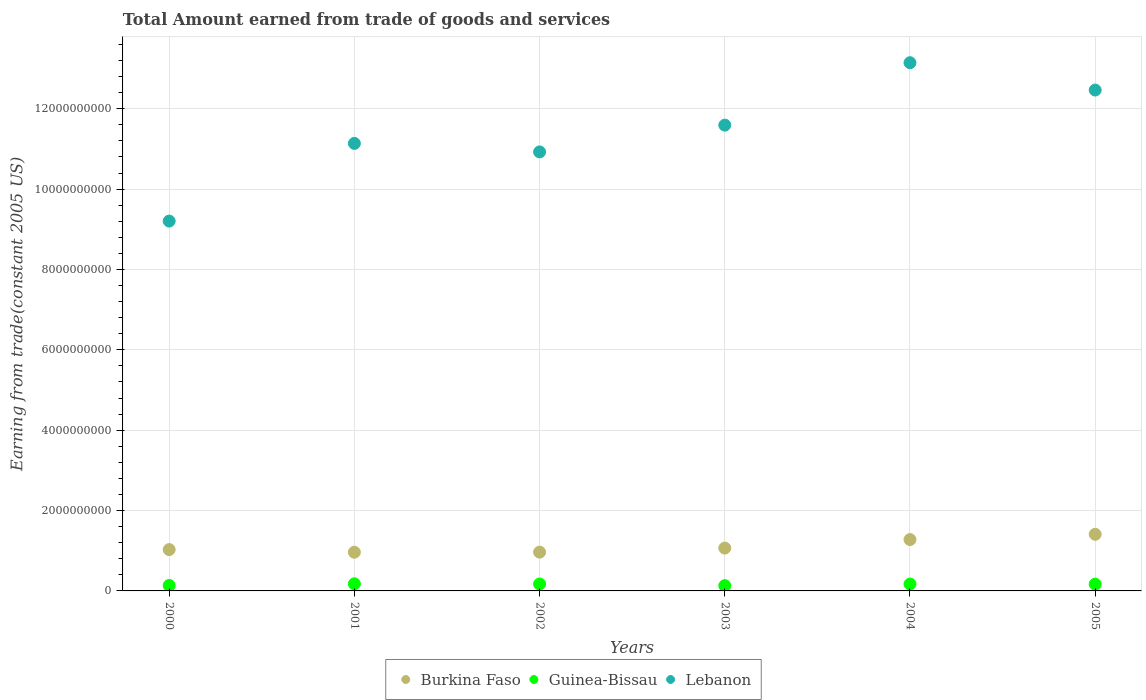What is the total amount earned by trading goods and services in Burkina Faso in 2001?
Give a very brief answer. 9.63e+08. Across all years, what is the maximum total amount earned by trading goods and services in Lebanon?
Your answer should be compact. 1.31e+1. Across all years, what is the minimum total amount earned by trading goods and services in Lebanon?
Your answer should be very brief. 9.20e+09. In which year was the total amount earned by trading goods and services in Burkina Faso maximum?
Your response must be concise. 2005. What is the total total amount earned by trading goods and services in Lebanon in the graph?
Keep it short and to the point. 6.85e+1. What is the difference between the total amount earned by trading goods and services in Burkina Faso in 2001 and that in 2002?
Ensure brevity in your answer.  -2.19e+06. What is the difference between the total amount earned by trading goods and services in Lebanon in 2005 and the total amount earned by trading goods and services in Burkina Faso in 2000?
Your response must be concise. 1.14e+1. What is the average total amount earned by trading goods and services in Lebanon per year?
Your response must be concise. 1.14e+1. In the year 2000, what is the difference between the total amount earned by trading goods and services in Guinea-Bissau and total amount earned by trading goods and services in Burkina Faso?
Give a very brief answer. -8.93e+08. In how many years, is the total amount earned by trading goods and services in Guinea-Bissau greater than 4400000000 US$?
Provide a succinct answer. 0. What is the ratio of the total amount earned by trading goods and services in Guinea-Bissau in 2001 to that in 2004?
Keep it short and to the point. 1.04. Is the total amount earned by trading goods and services in Guinea-Bissau in 2001 less than that in 2004?
Your answer should be compact. No. Is the difference between the total amount earned by trading goods and services in Guinea-Bissau in 2000 and 2003 greater than the difference between the total amount earned by trading goods and services in Burkina Faso in 2000 and 2003?
Provide a succinct answer. Yes. What is the difference between the highest and the second highest total amount earned by trading goods and services in Lebanon?
Make the answer very short. 6.80e+08. What is the difference between the highest and the lowest total amount earned by trading goods and services in Guinea-Bissau?
Provide a succinct answer. 4.55e+07. Is the sum of the total amount earned by trading goods and services in Guinea-Bissau in 2001 and 2005 greater than the maximum total amount earned by trading goods and services in Burkina Faso across all years?
Keep it short and to the point. No. Does the total amount earned by trading goods and services in Guinea-Bissau monotonically increase over the years?
Make the answer very short. No. Is the total amount earned by trading goods and services in Lebanon strictly less than the total amount earned by trading goods and services in Guinea-Bissau over the years?
Ensure brevity in your answer.  No. How many dotlines are there?
Offer a terse response. 3. How many years are there in the graph?
Provide a succinct answer. 6. Are the values on the major ticks of Y-axis written in scientific E-notation?
Your answer should be compact. No. What is the title of the graph?
Offer a terse response. Total Amount earned from trade of goods and services. What is the label or title of the X-axis?
Provide a succinct answer. Years. What is the label or title of the Y-axis?
Provide a short and direct response. Earning from trade(constant 2005 US). What is the Earning from trade(constant 2005 US) of Burkina Faso in 2000?
Your answer should be very brief. 1.03e+09. What is the Earning from trade(constant 2005 US) of Guinea-Bissau in 2000?
Keep it short and to the point. 1.35e+08. What is the Earning from trade(constant 2005 US) of Lebanon in 2000?
Ensure brevity in your answer.  9.20e+09. What is the Earning from trade(constant 2005 US) in Burkina Faso in 2001?
Your response must be concise. 9.63e+08. What is the Earning from trade(constant 2005 US) in Guinea-Bissau in 2001?
Provide a short and direct response. 1.77e+08. What is the Earning from trade(constant 2005 US) of Lebanon in 2001?
Offer a very short reply. 1.11e+1. What is the Earning from trade(constant 2005 US) of Burkina Faso in 2002?
Offer a very short reply. 9.65e+08. What is the Earning from trade(constant 2005 US) in Guinea-Bissau in 2002?
Offer a very short reply. 1.72e+08. What is the Earning from trade(constant 2005 US) in Lebanon in 2002?
Ensure brevity in your answer.  1.09e+1. What is the Earning from trade(constant 2005 US) in Burkina Faso in 2003?
Ensure brevity in your answer.  1.07e+09. What is the Earning from trade(constant 2005 US) in Guinea-Bissau in 2003?
Keep it short and to the point. 1.31e+08. What is the Earning from trade(constant 2005 US) in Lebanon in 2003?
Ensure brevity in your answer.  1.16e+1. What is the Earning from trade(constant 2005 US) in Burkina Faso in 2004?
Your answer should be very brief. 1.28e+09. What is the Earning from trade(constant 2005 US) in Guinea-Bissau in 2004?
Offer a terse response. 1.71e+08. What is the Earning from trade(constant 2005 US) of Lebanon in 2004?
Your answer should be very brief. 1.31e+1. What is the Earning from trade(constant 2005 US) in Burkina Faso in 2005?
Your answer should be very brief. 1.41e+09. What is the Earning from trade(constant 2005 US) in Guinea-Bissau in 2005?
Make the answer very short. 1.68e+08. What is the Earning from trade(constant 2005 US) of Lebanon in 2005?
Offer a very short reply. 1.25e+1. Across all years, what is the maximum Earning from trade(constant 2005 US) of Burkina Faso?
Give a very brief answer. 1.41e+09. Across all years, what is the maximum Earning from trade(constant 2005 US) of Guinea-Bissau?
Give a very brief answer. 1.77e+08. Across all years, what is the maximum Earning from trade(constant 2005 US) in Lebanon?
Give a very brief answer. 1.31e+1. Across all years, what is the minimum Earning from trade(constant 2005 US) in Burkina Faso?
Your answer should be very brief. 9.63e+08. Across all years, what is the minimum Earning from trade(constant 2005 US) in Guinea-Bissau?
Make the answer very short. 1.31e+08. Across all years, what is the minimum Earning from trade(constant 2005 US) in Lebanon?
Offer a very short reply. 9.20e+09. What is the total Earning from trade(constant 2005 US) of Burkina Faso in the graph?
Offer a terse response. 6.71e+09. What is the total Earning from trade(constant 2005 US) of Guinea-Bissau in the graph?
Keep it short and to the point. 9.54e+08. What is the total Earning from trade(constant 2005 US) of Lebanon in the graph?
Your response must be concise. 6.85e+1. What is the difference between the Earning from trade(constant 2005 US) in Burkina Faso in 2000 and that in 2001?
Your answer should be compact. 6.56e+07. What is the difference between the Earning from trade(constant 2005 US) in Guinea-Bissau in 2000 and that in 2001?
Offer a very short reply. -4.14e+07. What is the difference between the Earning from trade(constant 2005 US) in Lebanon in 2000 and that in 2001?
Offer a very short reply. -1.93e+09. What is the difference between the Earning from trade(constant 2005 US) of Burkina Faso in 2000 and that in 2002?
Make the answer very short. 6.34e+07. What is the difference between the Earning from trade(constant 2005 US) of Guinea-Bissau in 2000 and that in 2002?
Offer a terse response. -3.62e+07. What is the difference between the Earning from trade(constant 2005 US) in Lebanon in 2000 and that in 2002?
Offer a terse response. -1.72e+09. What is the difference between the Earning from trade(constant 2005 US) of Burkina Faso in 2000 and that in 2003?
Your response must be concise. -3.80e+07. What is the difference between the Earning from trade(constant 2005 US) in Guinea-Bissau in 2000 and that in 2003?
Keep it short and to the point. 4.17e+06. What is the difference between the Earning from trade(constant 2005 US) of Lebanon in 2000 and that in 2003?
Provide a succinct answer. -2.39e+09. What is the difference between the Earning from trade(constant 2005 US) in Burkina Faso in 2000 and that in 2004?
Your response must be concise. -2.49e+08. What is the difference between the Earning from trade(constant 2005 US) in Guinea-Bissau in 2000 and that in 2004?
Your response must be concise. -3.52e+07. What is the difference between the Earning from trade(constant 2005 US) of Lebanon in 2000 and that in 2004?
Your answer should be compact. -3.94e+09. What is the difference between the Earning from trade(constant 2005 US) of Burkina Faso in 2000 and that in 2005?
Make the answer very short. -3.80e+08. What is the difference between the Earning from trade(constant 2005 US) in Guinea-Bissau in 2000 and that in 2005?
Make the answer very short. -3.22e+07. What is the difference between the Earning from trade(constant 2005 US) in Lebanon in 2000 and that in 2005?
Ensure brevity in your answer.  -3.26e+09. What is the difference between the Earning from trade(constant 2005 US) of Burkina Faso in 2001 and that in 2002?
Offer a terse response. -2.19e+06. What is the difference between the Earning from trade(constant 2005 US) of Guinea-Bissau in 2001 and that in 2002?
Offer a terse response. 5.18e+06. What is the difference between the Earning from trade(constant 2005 US) of Lebanon in 2001 and that in 2002?
Offer a very short reply. 2.12e+08. What is the difference between the Earning from trade(constant 2005 US) in Burkina Faso in 2001 and that in 2003?
Your response must be concise. -1.04e+08. What is the difference between the Earning from trade(constant 2005 US) of Guinea-Bissau in 2001 and that in 2003?
Offer a terse response. 4.55e+07. What is the difference between the Earning from trade(constant 2005 US) in Lebanon in 2001 and that in 2003?
Give a very brief answer. -4.55e+08. What is the difference between the Earning from trade(constant 2005 US) of Burkina Faso in 2001 and that in 2004?
Keep it short and to the point. -3.15e+08. What is the difference between the Earning from trade(constant 2005 US) of Guinea-Bissau in 2001 and that in 2004?
Ensure brevity in your answer.  6.19e+06. What is the difference between the Earning from trade(constant 2005 US) of Lebanon in 2001 and that in 2004?
Your answer should be very brief. -2.01e+09. What is the difference between the Earning from trade(constant 2005 US) in Burkina Faso in 2001 and that in 2005?
Provide a succinct answer. -4.46e+08. What is the difference between the Earning from trade(constant 2005 US) in Guinea-Bissau in 2001 and that in 2005?
Keep it short and to the point. 9.18e+06. What is the difference between the Earning from trade(constant 2005 US) in Lebanon in 2001 and that in 2005?
Give a very brief answer. -1.33e+09. What is the difference between the Earning from trade(constant 2005 US) of Burkina Faso in 2002 and that in 2003?
Provide a short and direct response. -1.01e+08. What is the difference between the Earning from trade(constant 2005 US) of Guinea-Bissau in 2002 and that in 2003?
Give a very brief answer. 4.04e+07. What is the difference between the Earning from trade(constant 2005 US) of Lebanon in 2002 and that in 2003?
Provide a short and direct response. -6.66e+08. What is the difference between the Earning from trade(constant 2005 US) in Burkina Faso in 2002 and that in 2004?
Keep it short and to the point. -3.13e+08. What is the difference between the Earning from trade(constant 2005 US) of Guinea-Bissau in 2002 and that in 2004?
Your answer should be compact. 1.01e+06. What is the difference between the Earning from trade(constant 2005 US) in Lebanon in 2002 and that in 2004?
Provide a short and direct response. -2.22e+09. What is the difference between the Earning from trade(constant 2005 US) of Burkina Faso in 2002 and that in 2005?
Make the answer very short. -4.44e+08. What is the difference between the Earning from trade(constant 2005 US) in Guinea-Bissau in 2002 and that in 2005?
Keep it short and to the point. 4.01e+06. What is the difference between the Earning from trade(constant 2005 US) in Lebanon in 2002 and that in 2005?
Your answer should be compact. -1.54e+09. What is the difference between the Earning from trade(constant 2005 US) in Burkina Faso in 2003 and that in 2004?
Ensure brevity in your answer.  -2.11e+08. What is the difference between the Earning from trade(constant 2005 US) of Guinea-Bissau in 2003 and that in 2004?
Provide a succinct answer. -3.94e+07. What is the difference between the Earning from trade(constant 2005 US) of Lebanon in 2003 and that in 2004?
Ensure brevity in your answer.  -1.55e+09. What is the difference between the Earning from trade(constant 2005 US) in Burkina Faso in 2003 and that in 2005?
Make the answer very short. -3.42e+08. What is the difference between the Earning from trade(constant 2005 US) of Guinea-Bissau in 2003 and that in 2005?
Keep it short and to the point. -3.64e+07. What is the difference between the Earning from trade(constant 2005 US) in Lebanon in 2003 and that in 2005?
Your answer should be very brief. -8.73e+08. What is the difference between the Earning from trade(constant 2005 US) of Burkina Faso in 2004 and that in 2005?
Make the answer very short. -1.31e+08. What is the difference between the Earning from trade(constant 2005 US) in Guinea-Bissau in 2004 and that in 2005?
Make the answer very short. 2.99e+06. What is the difference between the Earning from trade(constant 2005 US) in Lebanon in 2004 and that in 2005?
Provide a succinct answer. 6.80e+08. What is the difference between the Earning from trade(constant 2005 US) in Burkina Faso in 2000 and the Earning from trade(constant 2005 US) in Guinea-Bissau in 2001?
Make the answer very short. 8.52e+08. What is the difference between the Earning from trade(constant 2005 US) of Burkina Faso in 2000 and the Earning from trade(constant 2005 US) of Lebanon in 2001?
Your answer should be compact. -1.01e+1. What is the difference between the Earning from trade(constant 2005 US) of Guinea-Bissau in 2000 and the Earning from trade(constant 2005 US) of Lebanon in 2001?
Your answer should be compact. -1.10e+1. What is the difference between the Earning from trade(constant 2005 US) in Burkina Faso in 2000 and the Earning from trade(constant 2005 US) in Guinea-Bissau in 2002?
Make the answer very short. 8.57e+08. What is the difference between the Earning from trade(constant 2005 US) in Burkina Faso in 2000 and the Earning from trade(constant 2005 US) in Lebanon in 2002?
Give a very brief answer. -9.90e+09. What is the difference between the Earning from trade(constant 2005 US) of Guinea-Bissau in 2000 and the Earning from trade(constant 2005 US) of Lebanon in 2002?
Make the answer very short. -1.08e+1. What is the difference between the Earning from trade(constant 2005 US) of Burkina Faso in 2000 and the Earning from trade(constant 2005 US) of Guinea-Bissau in 2003?
Provide a succinct answer. 8.97e+08. What is the difference between the Earning from trade(constant 2005 US) of Burkina Faso in 2000 and the Earning from trade(constant 2005 US) of Lebanon in 2003?
Ensure brevity in your answer.  -1.06e+1. What is the difference between the Earning from trade(constant 2005 US) of Guinea-Bissau in 2000 and the Earning from trade(constant 2005 US) of Lebanon in 2003?
Provide a succinct answer. -1.15e+1. What is the difference between the Earning from trade(constant 2005 US) in Burkina Faso in 2000 and the Earning from trade(constant 2005 US) in Guinea-Bissau in 2004?
Offer a very short reply. 8.58e+08. What is the difference between the Earning from trade(constant 2005 US) in Burkina Faso in 2000 and the Earning from trade(constant 2005 US) in Lebanon in 2004?
Your answer should be very brief. -1.21e+1. What is the difference between the Earning from trade(constant 2005 US) in Guinea-Bissau in 2000 and the Earning from trade(constant 2005 US) in Lebanon in 2004?
Give a very brief answer. -1.30e+1. What is the difference between the Earning from trade(constant 2005 US) of Burkina Faso in 2000 and the Earning from trade(constant 2005 US) of Guinea-Bissau in 2005?
Ensure brevity in your answer.  8.61e+08. What is the difference between the Earning from trade(constant 2005 US) of Burkina Faso in 2000 and the Earning from trade(constant 2005 US) of Lebanon in 2005?
Your answer should be very brief. -1.14e+1. What is the difference between the Earning from trade(constant 2005 US) in Guinea-Bissau in 2000 and the Earning from trade(constant 2005 US) in Lebanon in 2005?
Offer a terse response. -1.23e+1. What is the difference between the Earning from trade(constant 2005 US) of Burkina Faso in 2001 and the Earning from trade(constant 2005 US) of Guinea-Bissau in 2002?
Offer a very short reply. 7.91e+08. What is the difference between the Earning from trade(constant 2005 US) of Burkina Faso in 2001 and the Earning from trade(constant 2005 US) of Lebanon in 2002?
Keep it short and to the point. -9.96e+09. What is the difference between the Earning from trade(constant 2005 US) in Guinea-Bissau in 2001 and the Earning from trade(constant 2005 US) in Lebanon in 2002?
Keep it short and to the point. -1.07e+1. What is the difference between the Earning from trade(constant 2005 US) in Burkina Faso in 2001 and the Earning from trade(constant 2005 US) in Guinea-Bissau in 2003?
Your answer should be compact. 8.32e+08. What is the difference between the Earning from trade(constant 2005 US) of Burkina Faso in 2001 and the Earning from trade(constant 2005 US) of Lebanon in 2003?
Provide a succinct answer. -1.06e+1. What is the difference between the Earning from trade(constant 2005 US) of Guinea-Bissau in 2001 and the Earning from trade(constant 2005 US) of Lebanon in 2003?
Your answer should be very brief. -1.14e+1. What is the difference between the Earning from trade(constant 2005 US) in Burkina Faso in 2001 and the Earning from trade(constant 2005 US) in Guinea-Bissau in 2004?
Provide a succinct answer. 7.92e+08. What is the difference between the Earning from trade(constant 2005 US) in Burkina Faso in 2001 and the Earning from trade(constant 2005 US) in Lebanon in 2004?
Your response must be concise. -1.22e+1. What is the difference between the Earning from trade(constant 2005 US) of Guinea-Bissau in 2001 and the Earning from trade(constant 2005 US) of Lebanon in 2004?
Make the answer very short. -1.30e+1. What is the difference between the Earning from trade(constant 2005 US) of Burkina Faso in 2001 and the Earning from trade(constant 2005 US) of Guinea-Bissau in 2005?
Keep it short and to the point. 7.95e+08. What is the difference between the Earning from trade(constant 2005 US) in Burkina Faso in 2001 and the Earning from trade(constant 2005 US) in Lebanon in 2005?
Make the answer very short. -1.15e+1. What is the difference between the Earning from trade(constant 2005 US) in Guinea-Bissau in 2001 and the Earning from trade(constant 2005 US) in Lebanon in 2005?
Your answer should be very brief. -1.23e+1. What is the difference between the Earning from trade(constant 2005 US) in Burkina Faso in 2002 and the Earning from trade(constant 2005 US) in Guinea-Bissau in 2003?
Offer a very short reply. 8.34e+08. What is the difference between the Earning from trade(constant 2005 US) of Burkina Faso in 2002 and the Earning from trade(constant 2005 US) of Lebanon in 2003?
Give a very brief answer. -1.06e+1. What is the difference between the Earning from trade(constant 2005 US) in Guinea-Bissau in 2002 and the Earning from trade(constant 2005 US) in Lebanon in 2003?
Keep it short and to the point. -1.14e+1. What is the difference between the Earning from trade(constant 2005 US) in Burkina Faso in 2002 and the Earning from trade(constant 2005 US) in Guinea-Bissau in 2004?
Offer a terse response. 7.94e+08. What is the difference between the Earning from trade(constant 2005 US) in Burkina Faso in 2002 and the Earning from trade(constant 2005 US) in Lebanon in 2004?
Give a very brief answer. -1.22e+1. What is the difference between the Earning from trade(constant 2005 US) of Guinea-Bissau in 2002 and the Earning from trade(constant 2005 US) of Lebanon in 2004?
Make the answer very short. -1.30e+1. What is the difference between the Earning from trade(constant 2005 US) of Burkina Faso in 2002 and the Earning from trade(constant 2005 US) of Guinea-Bissau in 2005?
Ensure brevity in your answer.  7.97e+08. What is the difference between the Earning from trade(constant 2005 US) in Burkina Faso in 2002 and the Earning from trade(constant 2005 US) in Lebanon in 2005?
Your answer should be very brief. -1.15e+1. What is the difference between the Earning from trade(constant 2005 US) in Guinea-Bissau in 2002 and the Earning from trade(constant 2005 US) in Lebanon in 2005?
Your response must be concise. -1.23e+1. What is the difference between the Earning from trade(constant 2005 US) in Burkina Faso in 2003 and the Earning from trade(constant 2005 US) in Guinea-Bissau in 2004?
Ensure brevity in your answer.  8.96e+08. What is the difference between the Earning from trade(constant 2005 US) in Burkina Faso in 2003 and the Earning from trade(constant 2005 US) in Lebanon in 2004?
Ensure brevity in your answer.  -1.21e+1. What is the difference between the Earning from trade(constant 2005 US) in Guinea-Bissau in 2003 and the Earning from trade(constant 2005 US) in Lebanon in 2004?
Provide a succinct answer. -1.30e+1. What is the difference between the Earning from trade(constant 2005 US) of Burkina Faso in 2003 and the Earning from trade(constant 2005 US) of Guinea-Bissau in 2005?
Your answer should be very brief. 8.99e+08. What is the difference between the Earning from trade(constant 2005 US) in Burkina Faso in 2003 and the Earning from trade(constant 2005 US) in Lebanon in 2005?
Your answer should be compact. -1.14e+1. What is the difference between the Earning from trade(constant 2005 US) in Guinea-Bissau in 2003 and the Earning from trade(constant 2005 US) in Lebanon in 2005?
Your response must be concise. -1.23e+1. What is the difference between the Earning from trade(constant 2005 US) of Burkina Faso in 2004 and the Earning from trade(constant 2005 US) of Guinea-Bissau in 2005?
Offer a terse response. 1.11e+09. What is the difference between the Earning from trade(constant 2005 US) in Burkina Faso in 2004 and the Earning from trade(constant 2005 US) in Lebanon in 2005?
Your answer should be compact. -1.12e+1. What is the difference between the Earning from trade(constant 2005 US) in Guinea-Bissau in 2004 and the Earning from trade(constant 2005 US) in Lebanon in 2005?
Provide a short and direct response. -1.23e+1. What is the average Earning from trade(constant 2005 US) of Burkina Faso per year?
Ensure brevity in your answer.  1.12e+09. What is the average Earning from trade(constant 2005 US) of Guinea-Bissau per year?
Provide a short and direct response. 1.59e+08. What is the average Earning from trade(constant 2005 US) in Lebanon per year?
Keep it short and to the point. 1.14e+1. In the year 2000, what is the difference between the Earning from trade(constant 2005 US) in Burkina Faso and Earning from trade(constant 2005 US) in Guinea-Bissau?
Offer a very short reply. 8.93e+08. In the year 2000, what is the difference between the Earning from trade(constant 2005 US) in Burkina Faso and Earning from trade(constant 2005 US) in Lebanon?
Offer a terse response. -8.18e+09. In the year 2000, what is the difference between the Earning from trade(constant 2005 US) of Guinea-Bissau and Earning from trade(constant 2005 US) of Lebanon?
Keep it short and to the point. -9.07e+09. In the year 2001, what is the difference between the Earning from trade(constant 2005 US) of Burkina Faso and Earning from trade(constant 2005 US) of Guinea-Bissau?
Offer a very short reply. 7.86e+08. In the year 2001, what is the difference between the Earning from trade(constant 2005 US) of Burkina Faso and Earning from trade(constant 2005 US) of Lebanon?
Ensure brevity in your answer.  -1.02e+1. In the year 2001, what is the difference between the Earning from trade(constant 2005 US) in Guinea-Bissau and Earning from trade(constant 2005 US) in Lebanon?
Your response must be concise. -1.10e+1. In the year 2002, what is the difference between the Earning from trade(constant 2005 US) of Burkina Faso and Earning from trade(constant 2005 US) of Guinea-Bissau?
Provide a succinct answer. 7.93e+08. In the year 2002, what is the difference between the Earning from trade(constant 2005 US) of Burkina Faso and Earning from trade(constant 2005 US) of Lebanon?
Provide a succinct answer. -9.96e+09. In the year 2002, what is the difference between the Earning from trade(constant 2005 US) in Guinea-Bissau and Earning from trade(constant 2005 US) in Lebanon?
Your response must be concise. -1.08e+1. In the year 2003, what is the difference between the Earning from trade(constant 2005 US) in Burkina Faso and Earning from trade(constant 2005 US) in Guinea-Bissau?
Your response must be concise. 9.35e+08. In the year 2003, what is the difference between the Earning from trade(constant 2005 US) in Burkina Faso and Earning from trade(constant 2005 US) in Lebanon?
Your response must be concise. -1.05e+1. In the year 2003, what is the difference between the Earning from trade(constant 2005 US) of Guinea-Bissau and Earning from trade(constant 2005 US) of Lebanon?
Your response must be concise. -1.15e+1. In the year 2004, what is the difference between the Earning from trade(constant 2005 US) in Burkina Faso and Earning from trade(constant 2005 US) in Guinea-Bissau?
Offer a terse response. 1.11e+09. In the year 2004, what is the difference between the Earning from trade(constant 2005 US) of Burkina Faso and Earning from trade(constant 2005 US) of Lebanon?
Your response must be concise. -1.19e+1. In the year 2004, what is the difference between the Earning from trade(constant 2005 US) of Guinea-Bissau and Earning from trade(constant 2005 US) of Lebanon?
Make the answer very short. -1.30e+1. In the year 2005, what is the difference between the Earning from trade(constant 2005 US) in Burkina Faso and Earning from trade(constant 2005 US) in Guinea-Bissau?
Offer a very short reply. 1.24e+09. In the year 2005, what is the difference between the Earning from trade(constant 2005 US) of Burkina Faso and Earning from trade(constant 2005 US) of Lebanon?
Your answer should be compact. -1.11e+1. In the year 2005, what is the difference between the Earning from trade(constant 2005 US) in Guinea-Bissau and Earning from trade(constant 2005 US) in Lebanon?
Ensure brevity in your answer.  -1.23e+1. What is the ratio of the Earning from trade(constant 2005 US) of Burkina Faso in 2000 to that in 2001?
Provide a succinct answer. 1.07. What is the ratio of the Earning from trade(constant 2005 US) of Guinea-Bissau in 2000 to that in 2001?
Provide a short and direct response. 0.77. What is the ratio of the Earning from trade(constant 2005 US) in Lebanon in 2000 to that in 2001?
Give a very brief answer. 0.83. What is the ratio of the Earning from trade(constant 2005 US) in Burkina Faso in 2000 to that in 2002?
Provide a succinct answer. 1.07. What is the ratio of the Earning from trade(constant 2005 US) in Guinea-Bissau in 2000 to that in 2002?
Keep it short and to the point. 0.79. What is the ratio of the Earning from trade(constant 2005 US) of Lebanon in 2000 to that in 2002?
Your answer should be very brief. 0.84. What is the ratio of the Earning from trade(constant 2005 US) in Burkina Faso in 2000 to that in 2003?
Your answer should be compact. 0.96. What is the ratio of the Earning from trade(constant 2005 US) in Guinea-Bissau in 2000 to that in 2003?
Your answer should be compact. 1.03. What is the ratio of the Earning from trade(constant 2005 US) in Lebanon in 2000 to that in 2003?
Ensure brevity in your answer.  0.79. What is the ratio of the Earning from trade(constant 2005 US) of Burkina Faso in 2000 to that in 2004?
Your answer should be very brief. 0.8. What is the ratio of the Earning from trade(constant 2005 US) in Guinea-Bissau in 2000 to that in 2004?
Make the answer very short. 0.79. What is the ratio of the Earning from trade(constant 2005 US) in Lebanon in 2000 to that in 2004?
Your response must be concise. 0.7. What is the ratio of the Earning from trade(constant 2005 US) of Burkina Faso in 2000 to that in 2005?
Ensure brevity in your answer.  0.73. What is the ratio of the Earning from trade(constant 2005 US) of Guinea-Bissau in 2000 to that in 2005?
Provide a succinct answer. 0.81. What is the ratio of the Earning from trade(constant 2005 US) of Lebanon in 2000 to that in 2005?
Offer a very short reply. 0.74. What is the ratio of the Earning from trade(constant 2005 US) of Guinea-Bissau in 2001 to that in 2002?
Keep it short and to the point. 1.03. What is the ratio of the Earning from trade(constant 2005 US) of Lebanon in 2001 to that in 2002?
Ensure brevity in your answer.  1.02. What is the ratio of the Earning from trade(constant 2005 US) in Burkina Faso in 2001 to that in 2003?
Offer a terse response. 0.9. What is the ratio of the Earning from trade(constant 2005 US) of Guinea-Bissau in 2001 to that in 2003?
Ensure brevity in your answer.  1.35. What is the ratio of the Earning from trade(constant 2005 US) of Lebanon in 2001 to that in 2003?
Provide a succinct answer. 0.96. What is the ratio of the Earning from trade(constant 2005 US) in Burkina Faso in 2001 to that in 2004?
Your answer should be compact. 0.75. What is the ratio of the Earning from trade(constant 2005 US) in Guinea-Bissau in 2001 to that in 2004?
Your response must be concise. 1.04. What is the ratio of the Earning from trade(constant 2005 US) of Lebanon in 2001 to that in 2004?
Offer a very short reply. 0.85. What is the ratio of the Earning from trade(constant 2005 US) in Burkina Faso in 2001 to that in 2005?
Keep it short and to the point. 0.68. What is the ratio of the Earning from trade(constant 2005 US) in Guinea-Bissau in 2001 to that in 2005?
Provide a short and direct response. 1.05. What is the ratio of the Earning from trade(constant 2005 US) in Lebanon in 2001 to that in 2005?
Give a very brief answer. 0.89. What is the ratio of the Earning from trade(constant 2005 US) of Burkina Faso in 2002 to that in 2003?
Your answer should be compact. 0.91. What is the ratio of the Earning from trade(constant 2005 US) in Guinea-Bissau in 2002 to that in 2003?
Your answer should be compact. 1.31. What is the ratio of the Earning from trade(constant 2005 US) in Lebanon in 2002 to that in 2003?
Give a very brief answer. 0.94. What is the ratio of the Earning from trade(constant 2005 US) of Burkina Faso in 2002 to that in 2004?
Your answer should be compact. 0.76. What is the ratio of the Earning from trade(constant 2005 US) in Guinea-Bissau in 2002 to that in 2004?
Offer a terse response. 1.01. What is the ratio of the Earning from trade(constant 2005 US) in Lebanon in 2002 to that in 2004?
Your answer should be compact. 0.83. What is the ratio of the Earning from trade(constant 2005 US) in Burkina Faso in 2002 to that in 2005?
Give a very brief answer. 0.69. What is the ratio of the Earning from trade(constant 2005 US) of Guinea-Bissau in 2002 to that in 2005?
Your response must be concise. 1.02. What is the ratio of the Earning from trade(constant 2005 US) of Lebanon in 2002 to that in 2005?
Keep it short and to the point. 0.88. What is the ratio of the Earning from trade(constant 2005 US) of Burkina Faso in 2003 to that in 2004?
Provide a short and direct response. 0.83. What is the ratio of the Earning from trade(constant 2005 US) in Guinea-Bissau in 2003 to that in 2004?
Provide a succinct answer. 0.77. What is the ratio of the Earning from trade(constant 2005 US) in Lebanon in 2003 to that in 2004?
Keep it short and to the point. 0.88. What is the ratio of the Earning from trade(constant 2005 US) of Burkina Faso in 2003 to that in 2005?
Your answer should be compact. 0.76. What is the ratio of the Earning from trade(constant 2005 US) of Guinea-Bissau in 2003 to that in 2005?
Provide a short and direct response. 0.78. What is the ratio of the Earning from trade(constant 2005 US) in Burkina Faso in 2004 to that in 2005?
Make the answer very short. 0.91. What is the ratio of the Earning from trade(constant 2005 US) in Guinea-Bissau in 2004 to that in 2005?
Keep it short and to the point. 1.02. What is the ratio of the Earning from trade(constant 2005 US) in Lebanon in 2004 to that in 2005?
Keep it short and to the point. 1.05. What is the difference between the highest and the second highest Earning from trade(constant 2005 US) of Burkina Faso?
Offer a very short reply. 1.31e+08. What is the difference between the highest and the second highest Earning from trade(constant 2005 US) of Guinea-Bissau?
Make the answer very short. 5.18e+06. What is the difference between the highest and the second highest Earning from trade(constant 2005 US) in Lebanon?
Give a very brief answer. 6.80e+08. What is the difference between the highest and the lowest Earning from trade(constant 2005 US) in Burkina Faso?
Provide a succinct answer. 4.46e+08. What is the difference between the highest and the lowest Earning from trade(constant 2005 US) of Guinea-Bissau?
Offer a very short reply. 4.55e+07. What is the difference between the highest and the lowest Earning from trade(constant 2005 US) of Lebanon?
Offer a very short reply. 3.94e+09. 